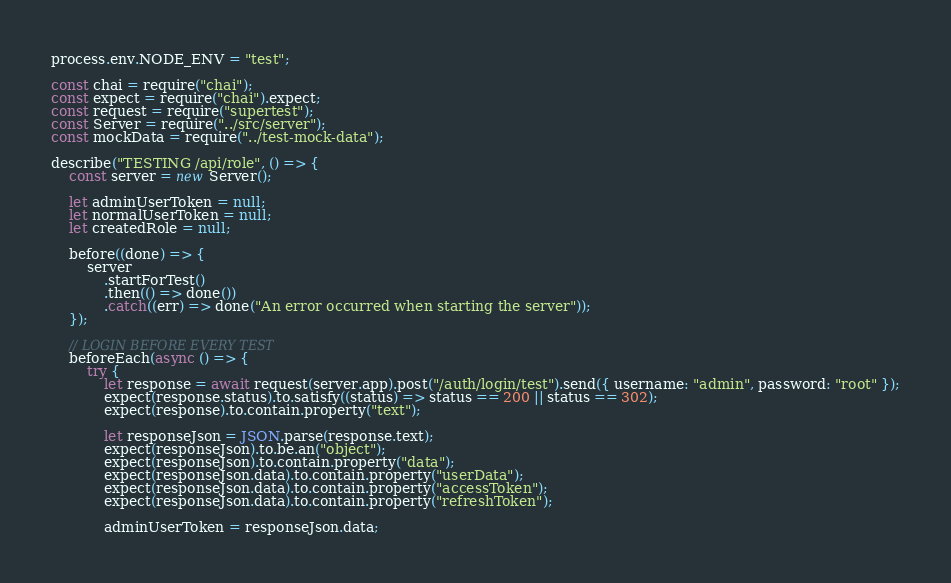<code> <loc_0><loc_0><loc_500><loc_500><_JavaScript_>process.env.NODE_ENV = "test";

const chai = require("chai");
const expect = require("chai").expect;
const request = require("supertest");
const Server = require("../src/server");
const mockData = require("../test-mock-data");

describe("TESTING /api/role", () => {
    const server = new Server();

    let adminUserToken = null;
    let normalUserToken = null;
    let createdRole = null;

    before((done) => {
        server
            .startForTest()
            .then(() => done())
            .catch((err) => done("An error occurred when starting the server"));
    });

    // LOGIN BEFORE EVERY TEST
    beforeEach(async () => {
        try {
            let response = await request(server.app).post("/auth/login/test").send({ username: "admin", password: "root" });
            expect(response.status).to.satisfy((status) => status == 200 || status == 302);
            expect(response).to.contain.property("text");

            let responseJson = JSON.parse(response.text);
            expect(responseJson).to.be.an("object");
            expect(responseJson).to.contain.property("data");
            expect(responseJson.data).to.contain.property("userData");
            expect(responseJson.data).to.contain.property("accessToken");
            expect(responseJson.data).to.contain.property("refreshToken");

            adminUserToken = responseJson.data;
</code> 